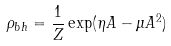<formula> <loc_0><loc_0><loc_500><loc_500>\rho _ { b h } = \frac { 1 } { Z } \exp ( \eta { A } - \mu { A } ^ { 2 } )</formula> 